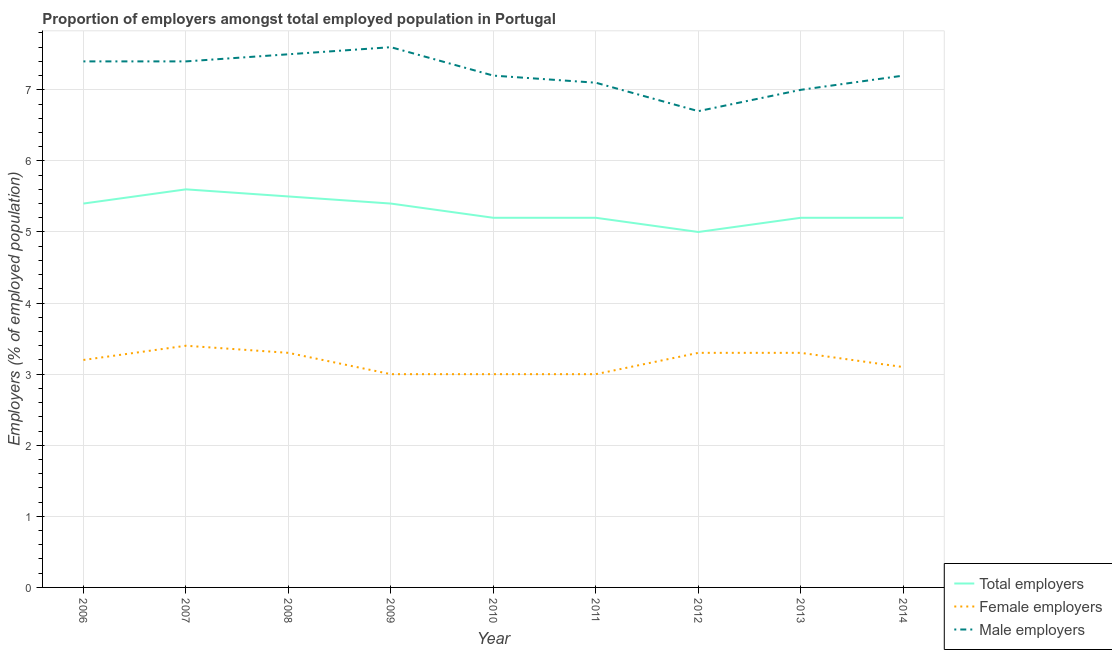How many different coloured lines are there?
Your answer should be very brief. 3. What is the percentage of male employers in 2007?
Your answer should be very brief. 7.4. Across all years, what is the maximum percentage of total employers?
Your answer should be compact. 5.6. Across all years, what is the minimum percentage of total employers?
Ensure brevity in your answer.  5. In which year was the percentage of male employers maximum?
Offer a very short reply. 2009. What is the total percentage of female employers in the graph?
Ensure brevity in your answer.  28.6. What is the difference between the percentage of male employers in 2007 and that in 2008?
Give a very brief answer. -0.1. What is the difference between the percentage of male employers in 2012 and the percentage of female employers in 2008?
Give a very brief answer. 3.4. What is the average percentage of male employers per year?
Your answer should be very brief. 7.23. In the year 2009, what is the difference between the percentage of female employers and percentage of male employers?
Offer a terse response. -4.6. In how many years, is the percentage of female employers greater than 3.4 %?
Make the answer very short. 1. What is the ratio of the percentage of male employers in 2006 to that in 2009?
Your response must be concise. 0.97. Is the difference between the percentage of male employers in 2010 and 2013 greater than the difference between the percentage of total employers in 2010 and 2013?
Give a very brief answer. Yes. What is the difference between the highest and the second highest percentage of total employers?
Offer a terse response. 0.1. What is the difference between the highest and the lowest percentage of total employers?
Provide a succinct answer. 0.6. In how many years, is the percentage of male employers greater than the average percentage of male employers taken over all years?
Make the answer very short. 4. Is the sum of the percentage of female employers in 2007 and 2012 greater than the maximum percentage of male employers across all years?
Offer a very short reply. No. Is it the case that in every year, the sum of the percentage of total employers and percentage of female employers is greater than the percentage of male employers?
Your answer should be very brief. Yes. Is the percentage of total employers strictly greater than the percentage of female employers over the years?
Your response must be concise. Yes. How many years are there in the graph?
Keep it short and to the point. 9. What is the difference between two consecutive major ticks on the Y-axis?
Give a very brief answer. 1. Does the graph contain grids?
Your answer should be very brief. Yes. Where does the legend appear in the graph?
Your response must be concise. Bottom right. How many legend labels are there?
Your response must be concise. 3. What is the title of the graph?
Provide a succinct answer. Proportion of employers amongst total employed population in Portugal. Does "Slovak Republic" appear as one of the legend labels in the graph?
Keep it short and to the point. No. What is the label or title of the X-axis?
Your answer should be very brief. Year. What is the label or title of the Y-axis?
Provide a succinct answer. Employers (% of employed population). What is the Employers (% of employed population) of Total employers in 2006?
Keep it short and to the point. 5.4. What is the Employers (% of employed population) of Female employers in 2006?
Offer a terse response. 3.2. What is the Employers (% of employed population) of Male employers in 2006?
Ensure brevity in your answer.  7.4. What is the Employers (% of employed population) in Total employers in 2007?
Make the answer very short. 5.6. What is the Employers (% of employed population) in Female employers in 2007?
Your response must be concise. 3.4. What is the Employers (% of employed population) of Male employers in 2007?
Your response must be concise. 7.4. What is the Employers (% of employed population) of Total employers in 2008?
Your answer should be very brief. 5.5. What is the Employers (% of employed population) of Female employers in 2008?
Your answer should be very brief. 3.3. What is the Employers (% of employed population) in Total employers in 2009?
Offer a very short reply. 5.4. What is the Employers (% of employed population) of Male employers in 2009?
Your answer should be compact. 7.6. What is the Employers (% of employed population) in Total employers in 2010?
Your answer should be compact. 5.2. What is the Employers (% of employed population) of Male employers in 2010?
Offer a terse response. 7.2. What is the Employers (% of employed population) of Total employers in 2011?
Your answer should be very brief. 5.2. What is the Employers (% of employed population) in Female employers in 2011?
Give a very brief answer. 3. What is the Employers (% of employed population) in Male employers in 2011?
Make the answer very short. 7.1. What is the Employers (% of employed population) of Female employers in 2012?
Your response must be concise. 3.3. What is the Employers (% of employed population) in Male employers in 2012?
Your answer should be compact. 6.7. What is the Employers (% of employed population) of Total employers in 2013?
Offer a very short reply. 5.2. What is the Employers (% of employed population) in Female employers in 2013?
Keep it short and to the point. 3.3. What is the Employers (% of employed population) in Male employers in 2013?
Provide a succinct answer. 7. What is the Employers (% of employed population) in Total employers in 2014?
Ensure brevity in your answer.  5.2. What is the Employers (% of employed population) of Female employers in 2014?
Provide a short and direct response. 3.1. What is the Employers (% of employed population) of Male employers in 2014?
Keep it short and to the point. 7.2. Across all years, what is the maximum Employers (% of employed population) in Total employers?
Your answer should be very brief. 5.6. Across all years, what is the maximum Employers (% of employed population) of Female employers?
Offer a terse response. 3.4. Across all years, what is the maximum Employers (% of employed population) of Male employers?
Your answer should be compact. 7.6. Across all years, what is the minimum Employers (% of employed population) in Total employers?
Offer a very short reply. 5. Across all years, what is the minimum Employers (% of employed population) in Male employers?
Provide a short and direct response. 6.7. What is the total Employers (% of employed population) in Total employers in the graph?
Make the answer very short. 47.7. What is the total Employers (% of employed population) of Female employers in the graph?
Make the answer very short. 28.6. What is the total Employers (% of employed population) of Male employers in the graph?
Your response must be concise. 65.1. What is the difference between the Employers (% of employed population) of Total employers in 2006 and that in 2007?
Offer a very short reply. -0.2. What is the difference between the Employers (% of employed population) of Male employers in 2006 and that in 2007?
Provide a short and direct response. 0. What is the difference between the Employers (% of employed population) in Female employers in 2006 and that in 2008?
Make the answer very short. -0.1. What is the difference between the Employers (% of employed population) in Male employers in 2006 and that in 2008?
Offer a terse response. -0.1. What is the difference between the Employers (% of employed population) of Female employers in 2006 and that in 2009?
Give a very brief answer. 0.2. What is the difference between the Employers (% of employed population) in Total employers in 2006 and that in 2014?
Make the answer very short. 0.2. What is the difference between the Employers (% of employed population) in Female employers in 2006 and that in 2014?
Your answer should be very brief. 0.1. What is the difference between the Employers (% of employed population) in Male employers in 2006 and that in 2014?
Make the answer very short. 0.2. What is the difference between the Employers (% of employed population) of Female employers in 2007 and that in 2008?
Make the answer very short. 0.1. What is the difference between the Employers (% of employed population) in Total employers in 2007 and that in 2010?
Your answer should be compact. 0.4. What is the difference between the Employers (% of employed population) of Female employers in 2007 and that in 2010?
Provide a short and direct response. 0.4. What is the difference between the Employers (% of employed population) in Male employers in 2007 and that in 2010?
Give a very brief answer. 0.2. What is the difference between the Employers (% of employed population) in Total employers in 2007 and that in 2011?
Keep it short and to the point. 0.4. What is the difference between the Employers (% of employed population) of Male employers in 2007 and that in 2012?
Make the answer very short. 0.7. What is the difference between the Employers (% of employed population) of Male employers in 2007 and that in 2014?
Your answer should be compact. 0.2. What is the difference between the Employers (% of employed population) of Total employers in 2008 and that in 2009?
Keep it short and to the point. 0.1. What is the difference between the Employers (% of employed population) of Female employers in 2008 and that in 2010?
Make the answer very short. 0.3. What is the difference between the Employers (% of employed population) of Male employers in 2008 and that in 2010?
Your answer should be very brief. 0.3. What is the difference between the Employers (% of employed population) of Male employers in 2008 and that in 2011?
Give a very brief answer. 0.4. What is the difference between the Employers (% of employed population) in Total employers in 2008 and that in 2013?
Ensure brevity in your answer.  0.3. What is the difference between the Employers (% of employed population) of Female employers in 2008 and that in 2013?
Your response must be concise. 0. What is the difference between the Employers (% of employed population) of Male employers in 2008 and that in 2013?
Provide a short and direct response. 0.5. What is the difference between the Employers (% of employed population) in Female employers in 2008 and that in 2014?
Provide a short and direct response. 0.2. What is the difference between the Employers (% of employed population) in Male employers in 2008 and that in 2014?
Offer a very short reply. 0.3. What is the difference between the Employers (% of employed population) in Female employers in 2009 and that in 2010?
Keep it short and to the point. 0. What is the difference between the Employers (% of employed population) in Male employers in 2009 and that in 2010?
Make the answer very short. 0.4. What is the difference between the Employers (% of employed population) in Total employers in 2009 and that in 2011?
Give a very brief answer. 0.2. What is the difference between the Employers (% of employed population) in Total employers in 2009 and that in 2013?
Provide a succinct answer. 0.2. What is the difference between the Employers (% of employed population) in Female employers in 2009 and that in 2013?
Provide a succinct answer. -0.3. What is the difference between the Employers (% of employed population) in Female employers in 2009 and that in 2014?
Your answer should be very brief. -0.1. What is the difference between the Employers (% of employed population) of Male employers in 2009 and that in 2014?
Give a very brief answer. 0.4. What is the difference between the Employers (% of employed population) in Total employers in 2010 and that in 2011?
Make the answer very short. 0. What is the difference between the Employers (% of employed population) of Total employers in 2010 and that in 2012?
Offer a terse response. 0.2. What is the difference between the Employers (% of employed population) of Female employers in 2010 and that in 2013?
Give a very brief answer. -0.3. What is the difference between the Employers (% of employed population) in Male employers in 2010 and that in 2013?
Offer a terse response. 0.2. What is the difference between the Employers (% of employed population) in Total employers in 2010 and that in 2014?
Keep it short and to the point. 0. What is the difference between the Employers (% of employed population) in Female employers in 2010 and that in 2014?
Give a very brief answer. -0.1. What is the difference between the Employers (% of employed population) in Male employers in 2010 and that in 2014?
Your answer should be compact. 0. What is the difference between the Employers (% of employed population) in Female employers in 2011 and that in 2013?
Provide a succinct answer. -0.3. What is the difference between the Employers (% of employed population) in Female employers in 2011 and that in 2014?
Make the answer very short. -0.1. What is the difference between the Employers (% of employed population) of Male employers in 2011 and that in 2014?
Provide a short and direct response. -0.1. What is the difference between the Employers (% of employed population) in Total employers in 2012 and that in 2013?
Offer a very short reply. -0.2. What is the difference between the Employers (% of employed population) in Female employers in 2012 and that in 2013?
Offer a terse response. 0. What is the difference between the Employers (% of employed population) in Male employers in 2012 and that in 2013?
Provide a short and direct response. -0.3. What is the difference between the Employers (% of employed population) in Male employers in 2012 and that in 2014?
Provide a short and direct response. -0.5. What is the difference between the Employers (% of employed population) of Female employers in 2013 and that in 2014?
Offer a very short reply. 0.2. What is the difference between the Employers (% of employed population) in Male employers in 2013 and that in 2014?
Keep it short and to the point. -0.2. What is the difference between the Employers (% of employed population) in Total employers in 2006 and the Employers (% of employed population) in Female employers in 2007?
Provide a short and direct response. 2. What is the difference between the Employers (% of employed population) of Total employers in 2006 and the Employers (% of employed population) of Male employers in 2007?
Offer a very short reply. -2. What is the difference between the Employers (% of employed population) in Female employers in 2006 and the Employers (% of employed population) in Male employers in 2007?
Provide a succinct answer. -4.2. What is the difference between the Employers (% of employed population) of Total employers in 2006 and the Employers (% of employed population) of Male employers in 2008?
Offer a terse response. -2.1. What is the difference between the Employers (% of employed population) of Female employers in 2006 and the Employers (% of employed population) of Male employers in 2009?
Your answer should be compact. -4.4. What is the difference between the Employers (% of employed population) of Total employers in 2006 and the Employers (% of employed population) of Female employers in 2010?
Offer a terse response. 2.4. What is the difference between the Employers (% of employed population) in Total employers in 2006 and the Employers (% of employed population) in Male employers in 2010?
Your answer should be very brief. -1.8. What is the difference between the Employers (% of employed population) in Female employers in 2006 and the Employers (% of employed population) in Male employers in 2010?
Provide a succinct answer. -4. What is the difference between the Employers (% of employed population) in Total employers in 2006 and the Employers (% of employed population) in Female employers in 2011?
Make the answer very short. 2.4. What is the difference between the Employers (% of employed population) in Total employers in 2006 and the Employers (% of employed population) in Male employers in 2011?
Provide a short and direct response. -1.7. What is the difference between the Employers (% of employed population) in Female employers in 2006 and the Employers (% of employed population) in Male employers in 2011?
Provide a short and direct response. -3.9. What is the difference between the Employers (% of employed population) of Female employers in 2006 and the Employers (% of employed population) of Male employers in 2012?
Offer a terse response. -3.5. What is the difference between the Employers (% of employed population) of Total employers in 2006 and the Employers (% of employed population) of Female employers in 2014?
Provide a succinct answer. 2.3. What is the difference between the Employers (% of employed population) in Total employers in 2007 and the Employers (% of employed population) in Male employers in 2008?
Offer a terse response. -1.9. What is the difference between the Employers (% of employed population) of Female employers in 2007 and the Employers (% of employed population) of Male employers in 2008?
Offer a terse response. -4.1. What is the difference between the Employers (% of employed population) of Total employers in 2007 and the Employers (% of employed population) of Male employers in 2009?
Your answer should be compact. -2. What is the difference between the Employers (% of employed population) in Total employers in 2007 and the Employers (% of employed population) in Male employers in 2010?
Keep it short and to the point. -1.6. What is the difference between the Employers (% of employed population) of Total employers in 2007 and the Employers (% of employed population) of Female employers in 2011?
Offer a very short reply. 2.6. What is the difference between the Employers (% of employed population) in Female employers in 2007 and the Employers (% of employed population) in Male employers in 2011?
Make the answer very short. -3.7. What is the difference between the Employers (% of employed population) of Total employers in 2007 and the Employers (% of employed population) of Female employers in 2012?
Your response must be concise. 2.3. What is the difference between the Employers (% of employed population) of Total employers in 2007 and the Employers (% of employed population) of Male employers in 2012?
Your response must be concise. -1.1. What is the difference between the Employers (% of employed population) of Total employers in 2007 and the Employers (% of employed population) of Female employers in 2013?
Make the answer very short. 2.3. What is the difference between the Employers (% of employed population) of Total employers in 2007 and the Employers (% of employed population) of Male employers in 2013?
Your answer should be compact. -1.4. What is the difference between the Employers (% of employed population) in Total employers in 2007 and the Employers (% of employed population) in Male employers in 2014?
Offer a very short reply. -1.6. What is the difference between the Employers (% of employed population) of Total employers in 2008 and the Employers (% of employed population) of Female employers in 2009?
Your response must be concise. 2.5. What is the difference between the Employers (% of employed population) of Female employers in 2008 and the Employers (% of employed population) of Male employers in 2009?
Keep it short and to the point. -4.3. What is the difference between the Employers (% of employed population) in Total employers in 2008 and the Employers (% of employed population) in Female employers in 2010?
Offer a terse response. 2.5. What is the difference between the Employers (% of employed population) in Total employers in 2008 and the Employers (% of employed population) in Male employers in 2010?
Your answer should be very brief. -1.7. What is the difference between the Employers (% of employed population) of Female employers in 2008 and the Employers (% of employed population) of Male employers in 2011?
Your response must be concise. -3.8. What is the difference between the Employers (% of employed population) in Total employers in 2008 and the Employers (% of employed population) in Male employers in 2012?
Give a very brief answer. -1.2. What is the difference between the Employers (% of employed population) in Total employers in 2008 and the Employers (% of employed population) in Female employers in 2013?
Your answer should be compact. 2.2. What is the difference between the Employers (% of employed population) in Total employers in 2008 and the Employers (% of employed population) in Male employers in 2014?
Provide a succinct answer. -1.7. What is the difference between the Employers (% of employed population) in Total employers in 2009 and the Employers (% of employed population) in Male employers in 2012?
Provide a short and direct response. -1.3. What is the difference between the Employers (% of employed population) of Total employers in 2009 and the Employers (% of employed population) of Female employers in 2013?
Provide a succinct answer. 2.1. What is the difference between the Employers (% of employed population) in Female employers in 2009 and the Employers (% of employed population) in Male employers in 2013?
Offer a very short reply. -4. What is the difference between the Employers (% of employed population) of Total employers in 2009 and the Employers (% of employed population) of Female employers in 2014?
Offer a terse response. 2.3. What is the difference between the Employers (% of employed population) of Total employers in 2010 and the Employers (% of employed population) of Female employers in 2011?
Your answer should be very brief. 2.2. What is the difference between the Employers (% of employed population) of Total employers in 2010 and the Employers (% of employed population) of Male employers in 2011?
Ensure brevity in your answer.  -1.9. What is the difference between the Employers (% of employed population) of Total employers in 2010 and the Employers (% of employed population) of Male employers in 2012?
Offer a terse response. -1.5. What is the difference between the Employers (% of employed population) in Total employers in 2010 and the Employers (% of employed population) in Male employers in 2013?
Offer a very short reply. -1.8. What is the difference between the Employers (% of employed population) in Total employers in 2010 and the Employers (% of employed population) in Female employers in 2014?
Your response must be concise. 2.1. What is the difference between the Employers (% of employed population) of Total employers in 2010 and the Employers (% of employed population) of Male employers in 2014?
Provide a short and direct response. -2. What is the difference between the Employers (% of employed population) of Total employers in 2011 and the Employers (% of employed population) of Female employers in 2012?
Give a very brief answer. 1.9. What is the difference between the Employers (% of employed population) in Female employers in 2011 and the Employers (% of employed population) in Male employers in 2012?
Keep it short and to the point. -3.7. What is the difference between the Employers (% of employed population) of Female employers in 2011 and the Employers (% of employed population) of Male employers in 2013?
Provide a succinct answer. -4. What is the difference between the Employers (% of employed population) in Total employers in 2011 and the Employers (% of employed population) in Female employers in 2014?
Offer a very short reply. 2.1. What is the difference between the Employers (% of employed population) of Total employers in 2012 and the Employers (% of employed population) of Female employers in 2013?
Make the answer very short. 1.7. What is the difference between the Employers (% of employed population) of Total employers in 2012 and the Employers (% of employed population) of Male employers in 2013?
Offer a very short reply. -2. What is the difference between the Employers (% of employed population) of Female employers in 2012 and the Employers (% of employed population) of Male employers in 2013?
Offer a terse response. -3.7. What is the difference between the Employers (% of employed population) of Total employers in 2012 and the Employers (% of employed population) of Female employers in 2014?
Your answer should be compact. 1.9. What is the difference between the Employers (% of employed population) in Total employers in 2012 and the Employers (% of employed population) in Male employers in 2014?
Keep it short and to the point. -2.2. What is the difference between the Employers (% of employed population) in Female employers in 2012 and the Employers (% of employed population) in Male employers in 2014?
Offer a terse response. -3.9. What is the difference between the Employers (% of employed population) of Total employers in 2013 and the Employers (% of employed population) of Female employers in 2014?
Your answer should be very brief. 2.1. What is the difference between the Employers (% of employed population) of Female employers in 2013 and the Employers (% of employed population) of Male employers in 2014?
Keep it short and to the point. -3.9. What is the average Employers (% of employed population) in Female employers per year?
Your answer should be compact. 3.18. What is the average Employers (% of employed population) of Male employers per year?
Your answer should be compact. 7.23. In the year 2006, what is the difference between the Employers (% of employed population) in Total employers and Employers (% of employed population) in Female employers?
Ensure brevity in your answer.  2.2. In the year 2006, what is the difference between the Employers (% of employed population) of Total employers and Employers (% of employed population) of Male employers?
Give a very brief answer. -2. In the year 2008, what is the difference between the Employers (% of employed population) of Female employers and Employers (% of employed population) of Male employers?
Ensure brevity in your answer.  -4.2. In the year 2009, what is the difference between the Employers (% of employed population) of Total employers and Employers (% of employed population) of Female employers?
Ensure brevity in your answer.  2.4. In the year 2010, what is the difference between the Employers (% of employed population) of Total employers and Employers (% of employed population) of Female employers?
Offer a very short reply. 2.2. In the year 2010, what is the difference between the Employers (% of employed population) in Female employers and Employers (% of employed population) in Male employers?
Your answer should be very brief. -4.2. In the year 2011, what is the difference between the Employers (% of employed population) of Female employers and Employers (% of employed population) of Male employers?
Ensure brevity in your answer.  -4.1. In the year 2012, what is the difference between the Employers (% of employed population) in Total employers and Employers (% of employed population) in Female employers?
Offer a terse response. 1.7. In the year 2012, what is the difference between the Employers (% of employed population) of Female employers and Employers (% of employed population) of Male employers?
Ensure brevity in your answer.  -3.4. In the year 2013, what is the difference between the Employers (% of employed population) of Total employers and Employers (% of employed population) of Female employers?
Your answer should be compact. 1.9. In the year 2013, what is the difference between the Employers (% of employed population) of Total employers and Employers (% of employed population) of Male employers?
Make the answer very short. -1.8. In the year 2014, what is the difference between the Employers (% of employed population) in Total employers and Employers (% of employed population) in Female employers?
Your answer should be very brief. 2.1. In the year 2014, what is the difference between the Employers (% of employed population) in Female employers and Employers (% of employed population) in Male employers?
Offer a terse response. -4.1. What is the ratio of the Employers (% of employed population) of Female employers in 2006 to that in 2007?
Your answer should be very brief. 0.94. What is the ratio of the Employers (% of employed population) of Male employers in 2006 to that in 2007?
Provide a succinct answer. 1. What is the ratio of the Employers (% of employed population) in Total employers in 2006 to that in 2008?
Offer a terse response. 0.98. What is the ratio of the Employers (% of employed population) in Female employers in 2006 to that in 2008?
Keep it short and to the point. 0.97. What is the ratio of the Employers (% of employed population) of Male employers in 2006 to that in 2008?
Provide a short and direct response. 0.99. What is the ratio of the Employers (% of employed population) in Total employers in 2006 to that in 2009?
Ensure brevity in your answer.  1. What is the ratio of the Employers (% of employed population) of Female employers in 2006 to that in 2009?
Your answer should be compact. 1.07. What is the ratio of the Employers (% of employed population) of Male employers in 2006 to that in 2009?
Provide a succinct answer. 0.97. What is the ratio of the Employers (% of employed population) in Female employers in 2006 to that in 2010?
Make the answer very short. 1.07. What is the ratio of the Employers (% of employed population) in Male employers in 2006 to that in 2010?
Your response must be concise. 1.03. What is the ratio of the Employers (% of employed population) of Female employers in 2006 to that in 2011?
Keep it short and to the point. 1.07. What is the ratio of the Employers (% of employed population) in Male employers in 2006 to that in 2011?
Your answer should be compact. 1.04. What is the ratio of the Employers (% of employed population) of Total employers in 2006 to that in 2012?
Offer a very short reply. 1.08. What is the ratio of the Employers (% of employed population) in Female employers in 2006 to that in 2012?
Offer a very short reply. 0.97. What is the ratio of the Employers (% of employed population) in Male employers in 2006 to that in 2012?
Keep it short and to the point. 1.1. What is the ratio of the Employers (% of employed population) of Total employers in 2006 to that in 2013?
Keep it short and to the point. 1.04. What is the ratio of the Employers (% of employed population) of Female employers in 2006 to that in 2013?
Make the answer very short. 0.97. What is the ratio of the Employers (% of employed population) of Male employers in 2006 to that in 2013?
Keep it short and to the point. 1.06. What is the ratio of the Employers (% of employed population) in Total employers in 2006 to that in 2014?
Offer a terse response. 1.04. What is the ratio of the Employers (% of employed population) in Female employers in 2006 to that in 2014?
Make the answer very short. 1.03. What is the ratio of the Employers (% of employed population) of Male employers in 2006 to that in 2014?
Offer a terse response. 1.03. What is the ratio of the Employers (% of employed population) of Total employers in 2007 to that in 2008?
Keep it short and to the point. 1.02. What is the ratio of the Employers (% of employed population) in Female employers in 2007 to that in 2008?
Ensure brevity in your answer.  1.03. What is the ratio of the Employers (% of employed population) in Male employers in 2007 to that in 2008?
Provide a short and direct response. 0.99. What is the ratio of the Employers (% of employed population) of Female employers in 2007 to that in 2009?
Your answer should be compact. 1.13. What is the ratio of the Employers (% of employed population) of Male employers in 2007 to that in 2009?
Ensure brevity in your answer.  0.97. What is the ratio of the Employers (% of employed population) in Female employers in 2007 to that in 2010?
Provide a short and direct response. 1.13. What is the ratio of the Employers (% of employed population) in Male employers in 2007 to that in 2010?
Keep it short and to the point. 1.03. What is the ratio of the Employers (% of employed population) of Female employers in 2007 to that in 2011?
Your answer should be compact. 1.13. What is the ratio of the Employers (% of employed population) in Male employers in 2007 to that in 2011?
Offer a terse response. 1.04. What is the ratio of the Employers (% of employed population) in Total employers in 2007 to that in 2012?
Offer a terse response. 1.12. What is the ratio of the Employers (% of employed population) of Female employers in 2007 to that in 2012?
Provide a succinct answer. 1.03. What is the ratio of the Employers (% of employed population) of Male employers in 2007 to that in 2012?
Offer a terse response. 1.1. What is the ratio of the Employers (% of employed population) of Female employers in 2007 to that in 2013?
Offer a terse response. 1.03. What is the ratio of the Employers (% of employed population) in Male employers in 2007 to that in 2013?
Provide a short and direct response. 1.06. What is the ratio of the Employers (% of employed population) of Female employers in 2007 to that in 2014?
Ensure brevity in your answer.  1.1. What is the ratio of the Employers (% of employed population) of Male employers in 2007 to that in 2014?
Your response must be concise. 1.03. What is the ratio of the Employers (% of employed population) in Total employers in 2008 to that in 2009?
Provide a short and direct response. 1.02. What is the ratio of the Employers (% of employed population) in Female employers in 2008 to that in 2009?
Ensure brevity in your answer.  1.1. What is the ratio of the Employers (% of employed population) in Male employers in 2008 to that in 2009?
Provide a succinct answer. 0.99. What is the ratio of the Employers (% of employed population) of Total employers in 2008 to that in 2010?
Your response must be concise. 1.06. What is the ratio of the Employers (% of employed population) of Female employers in 2008 to that in 2010?
Offer a terse response. 1.1. What is the ratio of the Employers (% of employed population) in Male employers in 2008 to that in 2010?
Your response must be concise. 1.04. What is the ratio of the Employers (% of employed population) of Total employers in 2008 to that in 2011?
Offer a terse response. 1.06. What is the ratio of the Employers (% of employed population) of Female employers in 2008 to that in 2011?
Provide a succinct answer. 1.1. What is the ratio of the Employers (% of employed population) of Male employers in 2008 to that in 2011?
Provide a short and direct response. 1.06. What is the ratio of the Employers (% of employed population) in Male employers in 2008 to that in 2012?
Your answer should be compact. 1.12. What is the ratio of the Employers (% of employed population) of Total employers in 2008 to that in 2013?
Keep it short and to the point. 1.06. What is the ratio of the Employers (% of employed population) of Male employers in 2008 to that in 2013?
Your response must be concise. 1.07. What is the ratio of the Employers (% of employed population) in Total employers in 2008 to that in 2014?
Offer a very short reply. 1.06. What is the ratio of the Employers (% of employed population) in Female employers in 2008 to that in 2014?
Provide a succinct answer. 1.06. What is the ratio of the Employers (% of employed population) in Male employers in 2008 to that in 2014?
Provide a short and direct response. 1.04. What is the ratio of the Employers (% of employed population) of Total employers in 2009 to that in 2010?
Your answer should be very brief. 1.04. What is the ratio of the Employers (% of employed population) of Female employers in 2009 to that in 2010?
Offer a terse response. 1. What is the ratio of the Employers (% of employed population) in Male employers in 2009 to that in 2010?
Provide a succinct answer. 1.06. What is the ratio of the Employers (% of employed population) of Female employers in 2009 to that in 2011?
Ensure brevity in your answer.  1. What is the ratio of the Employers (% of employed population) in Male employers in 2009 to that in 2011?
Your answer should be compact. 1.07. What is the ratio of the Employers (% of employed population) in Female employers in 2009 to that in 2012?
Your answer should be very brief. 0.91. What is the ratio of the Employers (% of employed population) in Male employers in 2009 to that in 2012?
Keep it short and to the point. 1.13. What is the ratio of the Employers (% of employed population) in Female employers in 2009 to that in 2013?
Ensure brevity in your answer.  0.91. What is the ratio of the Employers (% of employed population) of Male employers in 2009 to that in 2013?
Provide a short and direct response. 1.09. What is the ratio of the Employers (% of employed population) of Total employers in 2009 to that in 2014?
Your answer should be very brief. 1.04. What is the ratio of the Employers (% of employed population) of Female employers in 2009 to that in 2014?
Keep it short and to the point. 0.97. What is the ratio of the Employers (% of employed population) in Male employers in 2009 to that in 2014?
Your answer should be very brief. 1.06. What is the ratio of the Employers (% of employed population) of Total employers in 2010 to that in 2011?
Ensure brevity in your answer.  1. What is the ratio of the Employers (% of employed population) of Male employers in 2010 to that in 2011?
Your answer should be compact. 1.01. What is the ratio of the Employers (% of employed population) of Total employers in 2010 to that in 2012?
Your response must be concise. 1.04. What is the ratio of the Employers (% of employed population) of Male employers in 2010 to that in 2012?
Offer a very short reply. 1.07. What is the ratio of the Employers (% of employed population) of Total employers in 2010 to that in 2013?
Your answer should be compact. 1. What is the ratio of the Employers (% of employed population) in Male employers in 2010 to that in 2013?
Make the answer very short. 1.03. What is the ratio of the Employers (% of employed population) of Total employers in 2010 to that in 2014?
Give a very brief answer. 1. What is the ratio of the Employers (% of employed population) in Male employers in 2010 to that in 2014?
Your answer should be very brief. 1. What is the ratio of the Employers (% of employed population) of Total employers in 2011 to that in 2012?
Give a very brief answer. 1.04. What is the ratio of the Employers (% of employed population) in Male employers in 2011 to that in 2012?
Ensure brevity in your answer.  1.06. What is the ratio of the Employers (% of employed population) of Total employers in 2011 to that in 2013?
Your answer should be very brief. 1. What is the ratio of the Employers (% of employed population) in Male employers in 2011 to that in 2013?
Your answer should be very brief. 1.01. What is the ratio of the Employers (% of employed population) in Male employers in 2011 to that in 2014?
Give a very brief answer. 0.99. What is the ratio of the Employers (% of employed population) of Total employers in 2012 to that in 2013?
Keep it short and to the point. 0.96. What is the ratio of the Employers (% of employed population) of Female employers in 2012 to that in 2013?
Your response must be concise. 1. What is the ratio of the Employers (% of employed population) in Male employers in 2012 to that in 2013?
Give a very brief answer. 0.96. What is the ratio of the Employers (% of employed population) in Total employers in 2012 to that in 2014?
Keep it short and to the point. 0.96. What is the ratio of the Employers (% of employed population) in Female employers in 2012 to that in 2014?
Your answer should be compact. 1.06. What is the ratio of the Employers (% of employed population) in Male employers in 2012 to that in 2014?
Offer a very short reply. 0.93. What is the ratio of the Employers (% of employed population) of Total employers in 2013 to that in 2014?
Keep it short and to the point. 1. What is the ratio of the Employers (% of employed population) in Female employers in 2013 to that in 2014?
Your response must be concise. 1.06. What is the ratio of the Employers (% of employed population) of Male employers in 2013 to that in 2014?
Keep it short and to the point. 0.97. What is the difference between the highest and the second highest Employers (% of employed population) in Total employers?
Offer a terse response. 0.1. What is the difference between the highest and the lowest Employers (% of employed population) of Total employers?
Your answer should be very brief. 0.6. What is the difference between the highest and the lowest Employers (% of employed population) in Male employers?
Give a very brief answer. 0.9. 